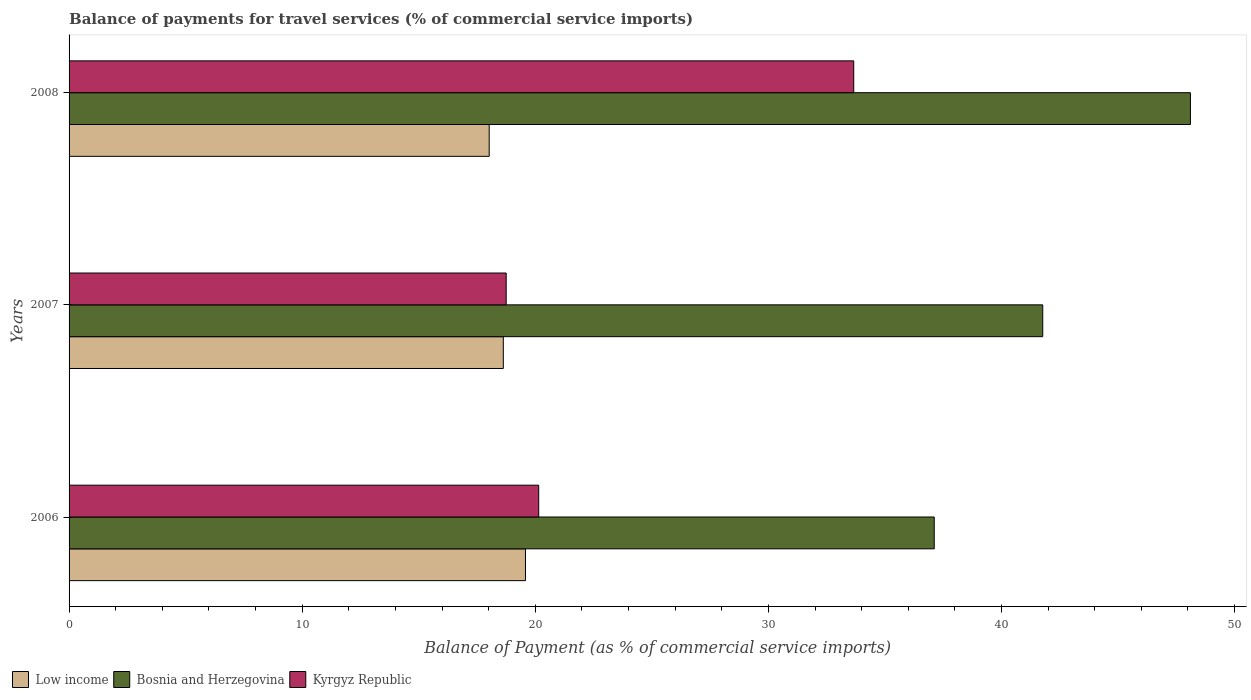How many different coloured bars are there?
Ensure brevity in your answer.  3. How many groups of bars are there?
Offer a very short reply. 3. Are the number of bars on each tick of the Y-axis equal?
Give a very brief answer. Yes. What is the label of the 2nd group of bars from the top?
Give a very brief answer. 2007. In how many cases, is the number of bars for a given year not equal to the number of legend labels?
Provide a short and direct response. 0. What is the balance of payments for travel services in Kyrgyz Republic in 2006?
Offer a very short reply. 20.15. Across all years, what is the maximum balance of payments for travel services in Low income?
Provide a succinct answer. 19.58. Across all years, what is the minimum balance of payments for travel services in Bosnia and Herzegovina?
Provide a short and direct response. 37.12. In which year was the balance of payments for travel services in Kyrgyz Republic maximum?
Ensure brevity in your answer.  2008. What is the total balance of payments for travel services in Low income in the graph?
Provide a short and direct response. 56.23. What is the difference between the balance of payments for travel services in Low income in 2007 and that in 2008?
Provide a short and direct response. 0.61. What is the difference between the balance of payments for travel services in Kyrgyz Republic in 2006 and the balance of payments for travel services in Low income in 2008?
Provide a succinct answer. 2.12. What is the average balance of payments for travel services in Low income per year?
Ensure brevity in your answer.  18.74. In the year 2006, what is the difference between the balance of payments for travel services in Kyrgyz Republic and balance of payments for travel services in Bosnia and Herzegovina?
Give a very brief answer. -16.97. What is the ratio of the balance of payments for travel services in Kyrgyz Republic in 2006 to that in 2007?
Your answer should be compact. 1.07. Is the balance of payments for travel services in Kyrgyz Republic in 2006 less than that in 2008?
Your answer should be compact. Yes. What is the difference between the highest and the second highest balance of payments for travel services in Kyrgyz Republic?
Offer a very short reply. 13.51. What is the difference between the highest and the lowest balance of payments for travel services in Low income?
Your answer should be compact. 1.56. What does the 2nd bar from the top in 2007 represents?
Give a very brief answer. Bosnia and Herzegovina. What does the 2nd bar from the bottom in 2008 represents?
Your answer should be very brief. Bosnia and Herzegovina. What is the difference between two consecutive major ticks on the X-axis?
Give a very brief answer. 10. Are the values on the major ticks of X-axis written in scientific E-notation?
Your response must be concise. No. Does the graph contain grids?
Ensure brevity in your answer.  No. Where does the legend appear in the graph?
Your answer should be very brief. Bottom left. How many legend labels are there?
Provide a succinct answer. 3. What is the title of the graph?
Your answer should be very brief. Balance of payments for travel services (% of commercial service imports). Does "Afghanistan" appear as one of the legend labels in the graph?
Your answer should be very brief. No. What is the label or title of the X-axis?
Provide a short and direct response. Balance of Payment (as % of commercial service imports). What is the Balance of Payment (as % of commercial service imports) in Low income in 2006?
Your response must be concise. 19.58. What is the Balance of Payment (as % of commercial service imports) of Bosnia and Herzegovina in 2006?
Provide a short and direct response. 37.12. What is the Balance of Payment (as % of commercial service imports) in Kyrgyz Republic in 2006?
Your answer should be compact. 20.15. What is the Balance of Payment (as % of commercial service imports) of Low income in 2007?
Ensure brevity in your answer.  18.63. What is the Balance of Payment (as % of commercial service imports) of Bosnia and Herzegovina in 2007?
Make the answer very short. 41.77. What is the Balance of Payment (as % of commercial service imports) in Kyrgyz Republic in 2007?
Provide a short and direct response. 18.75. What is the Balance of Payment (as % of commercial service imports) of Low income in 2008?
Provide a short and direct response. 18.02. What is the Balance of Payment (as % of commercial service imports) of Bosnia and Herzegovina in 2008?
Provide a succinct answer. 48.11. What is the Balance of Payment (as % of commercial service imports) in Kyrgyz Republic in 2008?
Keep it short and to the point. 33.66. Across all years, what is the maximum Balance of Payment (as % of commercial service imports) of Low income?
Your response must be concise. 19.58. Across all years, what is the maximum Balance of Payment (as % of commercial service imports) of Bosnia and Herzegovina?
Keep it short and to the point. 48.11. Across all years, what is the maximum Balance of Payment (as % of commercial service imports) of Kyrgyz Republic?
Give a very brief answer. 33.66. Across all years, what is the minimum Balance of Payment (as % of commercial service imports) in Low income?
Give a very brief answer. 18.02. Across all years, what is the minimum Balance of Payment (as % of commercial service imports) in Bosnia and Herzegovina?
Offer a terse response. 37.12. Across all years, what is the minimum Balance of Payment (as % of commercial service imports) in Kyrgyz Republic?
Provide a short and direct response. 18.75. What is the total Balance of Payment (as % of commercial service imports) in Low income in the graph?
Provide a short and direct response. 56.23. What is the total Balance of Payment (as % of commercial service imports) of Bosnia and Herzegovina in the graph?
Provide a short and direct response. 126.99. What is the total Balance of Payment (as % of commercial service imports) in Kyrgyz Republic in the graph?
Your answer should be very brief. 72.56. What is the difference between the Balance of Payment (as % of commercial service imports) in Low income in 2006 and that in 2007?
Your answer should be very brief. 0.95. What is the difference between the Balance of Payment (as % of commercial service imports) in Bosnia and Herzegovina in 2006 and that in 2007?
Make the answer very short. -4.66. What is the difference between the Balance of Payment (as % of commercial service imports) of Kyrgyz Republic in 2006 and that in 2007?
Provide a short and direct response. 1.4. What is the difference between the Balance of Payment (as % of commercial service imports) in Low income in 2006 and that in 2008?
Provide a succinct answer. 1.56. What is the difference between the Balance of Payment (as % of commercial service imports) in Bosnia and Herzegovina in 2006 and that in 2008?
Give a very brief answer. -10.99. What is the difference between the Balance of Payment (as % of commercial service imports) in Kyrgyz Republic in 2006 and that in 2008?
Offer a terse response. -13.51. What is the difference between the Balance of Payment (as % of commercial service imports) in Low income in 2007 and that in 2008?
Give a very brief answer. 0.61. What is the difference between the Balance of Payment (as % of commercial service imports) in Bosnia and Herzegovina in 2007 and that in 2008?
Offer a very short reply. -6.34. What is the difference between the Balance of Payment (as % of commercial service imports) in Kyrgyz Republic in 2007 and that in 2008?
Your answer should be compact. -14.91. What is the difference between the Balance of Payment (as % of commercial service imports) in Low income in 2006 and the Balance of Payment (as % of commercial service imports) in Bosnia and Herzegovina in 2007?
Provide a short and direct response. -22.19. What is the difference between the Balance of Payment (as % of commercial service imports) of Low income in 2006 and the Balance of Payment (as % of commercial service imports) of Kyrgyz Republic in 2007?
Provide a short and direct response. 0.83. What is the difference between the Balance of Payment (as % of commercial service imports) in Bosnia and Herzegovina in 2006 and the Balance of Payment (as % of commercial service imports) in Kyrgyz Republic in 2007?
Your answer should be very brief. 18.36. What is the difference between the Balance of Payment (as % of commercial service imports) of Low income in 2006 and the Balance of Payment (as % of commercial service imports) of Bosnia and Herzegovina in 2008?
Offer a very short reply. -28.53. What is the difference between the Balance of Payment (as % of commercial service imports) of Low income in 2006 and the Balance of Payment (as % of commercial service imports) of Kyrgyz Republic in 2008?
Provide a short and direct response. -14.08. What is the difference between the Balance of Payment (as % of commercial service imports) of Bosnia and Herzegovina in 2006 and the Balance of Payment (as % of commercial service imports) of Kyrgyz Republic in 2008?
Make the answer very short. 3.45. What is the difference between the Balance of Payment (as % of commercial service imports) in Low income in 2007 and the Balance of Payment (as % of commercial service imports) in Bosnia and Herzegovina in 2008?
Offer a very short reply. -29.48. What is the difference between the Balance of Payment (as % of commercial service imports) in Low income in 2007 and the Balance of Payment (as % of commercial service imports) in Kyrgyz Republic in 2008?
Offer a very short reply. -15.03. What is the difference between the Balance of Payment (as % of commercial service imports) in Bosnia and Herzegovina in 2007 and the Balance of Payment (as % of commercial service imports) in Kyrgyz Republic in 2008?
Provide a succinct answer. 8.11. What is the average Balance of Payment (as % of commercial service imports) in Low income per year?
Your answer should be compact. 18.74. What is the average Balance of Payment (as % of commercial service imports) of Bosnia and Herzegovina per year?
Provide a succinct answer. 42.33. What is the average Balance of Payment (as % of commercial service imports) of Kyrgyz Republic per year?
Make the answer very short. 24.19. In the year 2006, what is the difference between the Balance of Payment (as % of commercial service imports) in Low income and Balance of Payment (as % of commercial service imports) in Bosnia and Herzegovina?
Give a very brief answer. -17.54. In the year 2006, what is the difference between the Balance of Payment (as % of commercial service imports) of Low income and Balance of Payment (as % of commercial service imports) of Kyrgyz Republic?
Your answer should be very brief. -0.57. In the year 2006, what is the difference between the Balance of Payment (as % of commercial service imports) of Bosnia and Herzegovina and Balance of Payment (as % of commercial service imports) of Kyrgyz Republic?
Provide a short and direct response. 16.97. In the year 2007, what is the difference between the Balance of Payment (as % of commercial service imports) of Low income and Balance of Payment (as % of commercial service imports) of Bosnia and Herzegovina?
Ensure brevity in your answer.  -23.14. In the year 2007, what is the difference between the Balance of Payment (as % of commercial service imports) in Low income and Balance of Payment (as % of commercial service imports) in Kyrgyz Republic?
Provide a short and direct response. -0.12. In the year 2007, what is the difference between the Balance of Payment (as % of commercial service imports) of Bosnia and Herzegovina and Balance of Payment (as % of commercial service imports) of Kyrgyz Republic?
Your answer should be very brief. 23.02. In the year 2008, what is the difference between the Balance of Payment (as % of commercial service imports) of Low income and Balance of Payment (as % of commercial service imports) of Bosnia and Herzegovina?
Offer a terse response. -30.08. In the year 2008, what is the difference between the Balance of Payment (as % of commercial service imports) of Low income and Balance of Payment (as % of commercial service imports) of Kyrgyz Republic?
Give a very brief answer. -15.64. In the year 2008, what is the difference between the Balance of Payment (as % of commercial service imports) of Bosnia and Herzegovina and Balance of Payment (as % of commercial service imports) of Kyrgyz Republic?
Ensure brevity in your answer.  14.44. What is the ratio of the Balance of Payment (as % of commercial service imports) in Low income in 2006 to that in 2007?
Your response must be concise. 1.05. What is the ratio of the Balance of Payment (as % of commercial service imports) of Bosnia and Herzegovina in 2006 to that in 2007?
Provide a succinct answer. 0.89. What is the ratio of the Balance of Payment (as % of commercial service imports) of Kyrgyz Republic in 2006 to that in 2007?
Ensure brevity in your answer.  1.07. What is the ratio of the Balance of Payment (as % of commercial service imports) of Low income in 2006 to that in 2008?
Make the answer very short. 1.09. What is the ratio of the Balance of Payment (as % of commercial service imports) of Bosnia and Herzegovina in 2006 to that in 2008?
Provide a short and direct response. 0.77. What is the ratio of the Balance of Payment (as % of commercial service imports) of Kyrgyz Republic in 2006 to that in 2008?
Offer a terse response. 0.6. What is the ratio of the Balance of Payment (as % of commercial service imports) of Low income in 2007 to that in 2008?
Keep it short and to the point. 1.03. What is the ratio of the Balance of Payment (as % of commercial service imports) in Bosnia and Herzegovina in 2007 to that in 2008?
Ensure brevity in your answer.  0.87. What is the ratio of the Balance of Payment (as % of commercial service imports) in Kyrgyz Republic in 2007 to that in 2008?
Give a very brief answer. 0.56. What is the difference between the highest and the second highest Balance of Payment (as % of commercial service imports) of Low income?
Provide a succinct answer. 0.95. What is the difference between the highest and the second highest Balance of Payment (as % of commercial service imports) in Bosnia and Herzegovina?
Ensure brevity in your answer.  6.34. What is the difference between the highest and the second highest Balance of Payment (as % of commercial service imports) of Kyrgyz Republic?
Provide a short and direct response. 13.51. What is the difference between the highest and the lowest Balance of Payment (as % of commercial service imports) in Low income?
Ensure brevity in your answer.  1.56. What is the difference between the highest and the lowest Balance of Payment (as % of commercial service imports) in Bosnia and Herzegovina?
Your answer should be compact. 10.99. What is the difference between the highest and the lowest Balance of Payment (as % of commercial service imports) in Kyrgyz Republic?
Your answer should be compact. 14.91. 